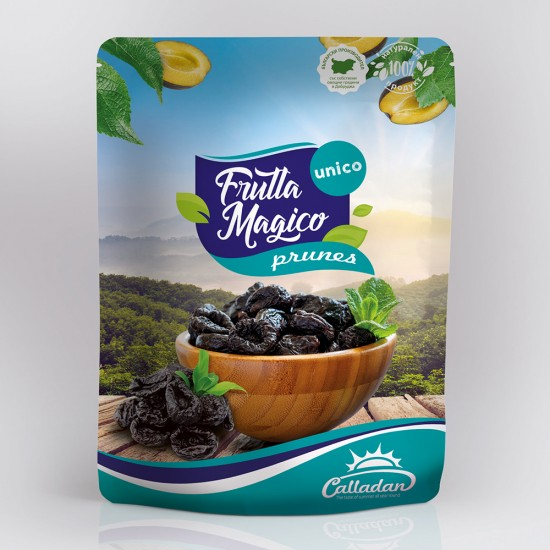How might the packaging design influence the consumer's perception of the prunes? The packaging design, featuring vibrant imagery of lemon slices, mint leaves, and a serene background, likely aims to give the product a fresh, natural, and premium feel. Consumers might perceive the prunes as not only delicious due to the depicted combination but also as healthy and high-quality, suitable for sophisticated palates. The use of bright colors and appealing nature imagery can attract attention and communicate the product's unique selling points effectively. 